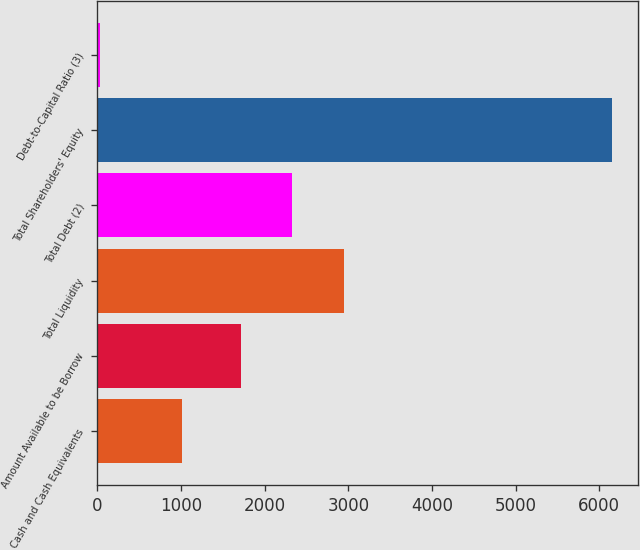Convert chart to OTSL. <chart><loc_0><loc_0><loc_500><loc_500><bar_chart><fcel>Cash and Cash Equivalents<fcel>Amount Available to be Borrow<fcel>Total Liquidity<fcel>Total Debt (2)<fcel>Total Shareholders' Equity<fcel>Debt-to-Capital Ratio (3)<nl><fcel>1014<fcel>1718<fcel>2944.4<fcel>2331.2<fcel>6157<fcel>25<nl></chart> 